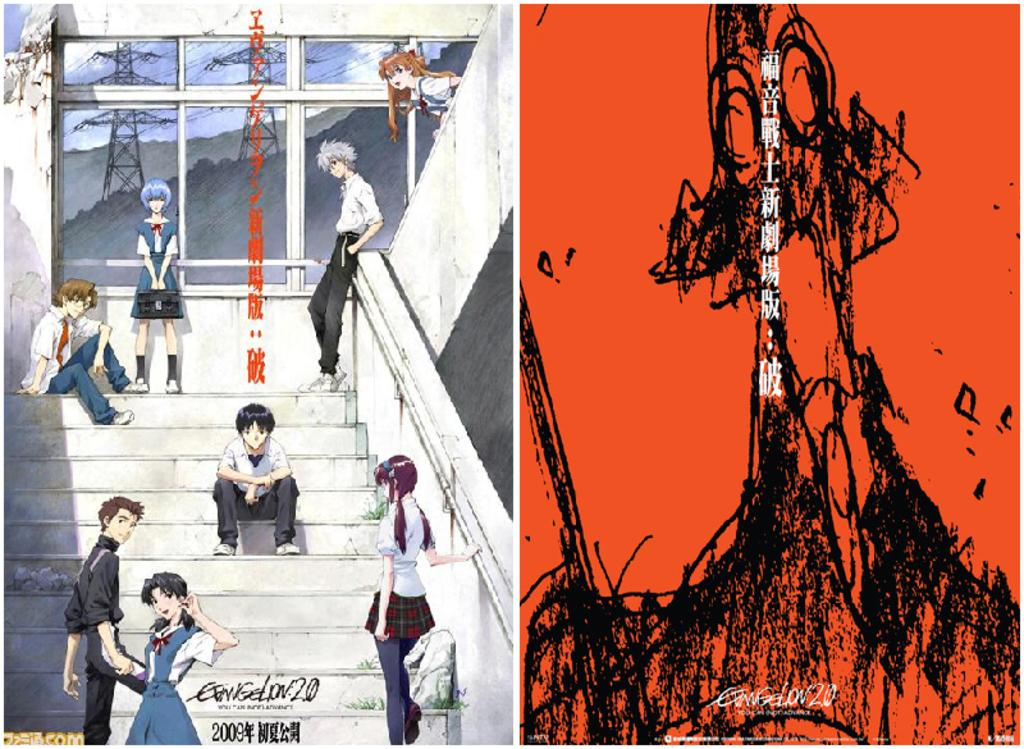<image>
Give a short and clear explanation of the subsequent image. Anime sitting on some steps with the word Evangelion on the bottom. 